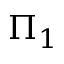Convert formula to latex. <formula><loc_0><loc_0><loc_500><loc_500>\Pi _ { 1 }</formula> 